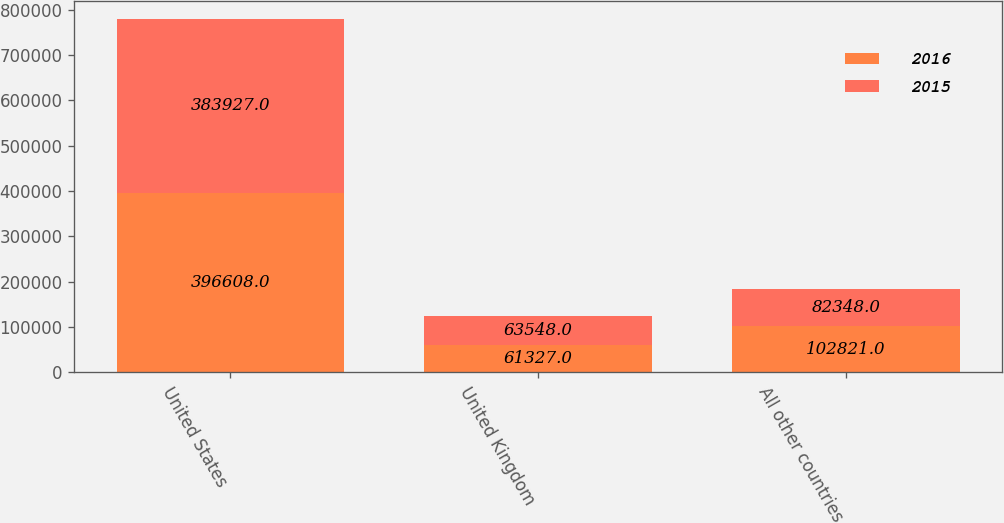Convert chart. <chart><loc_0><loc_0><loc_500><loc_500><stacked_bar_chart><ecel><fcel>United States<fcel>United Kingdom<fcel>All other countries<nl><fcel>2016<fcel>396608<fcel>61327<fcel>102821<nl><fcel>2015<fcel>383927<fcel>63548<fcel>82348<nl></chart> 